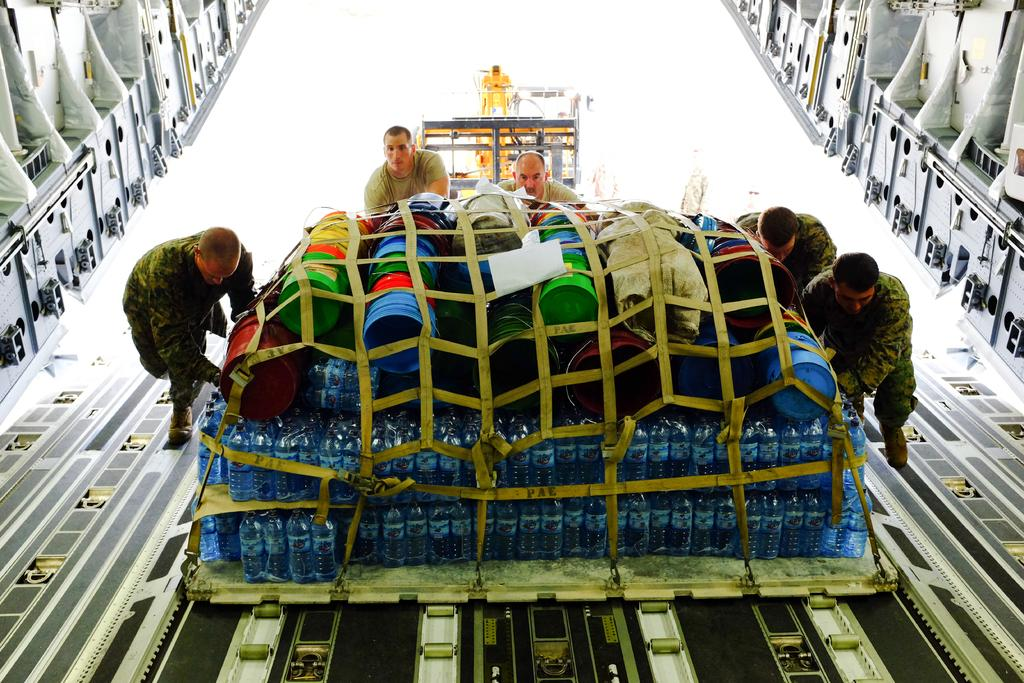What objects are present in the image in a group? There is a group of bottles in the image. What other items can be seen in the image? There are mats in the image. What are the persons in the image doing with the bottles and mats? The persons are pushing the bottles and mats into an aircraft. What can be seen in the background of the image? There is a vehicle visible in the background, and there are additional persons present. What time of day is indicated by the hour in the image? There is no hour present in the image, so it is not possible to determine the time of day. What type of letter is being delivered by the persons in the image? There is no letter being delivered in the image; the persons are pushing bottles and mats into an aircraft. 